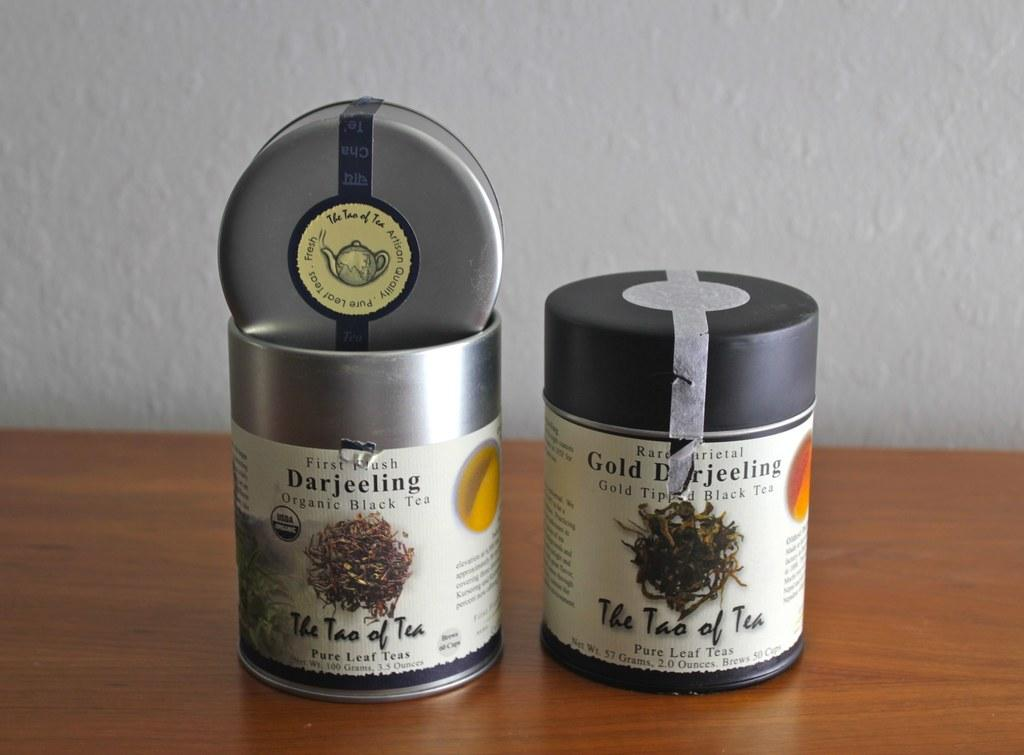How many bottles are on the table in the image? There are two bottles on the table in the image. What can be found on the bottles? There is text on the bottles. What is visible behind the table in the image? There is a wall at the back of the image. Can you describe the kiss between the two bottles in the image? There is no kiss between the two bottles in the image; they are simply bottles with text on them. 